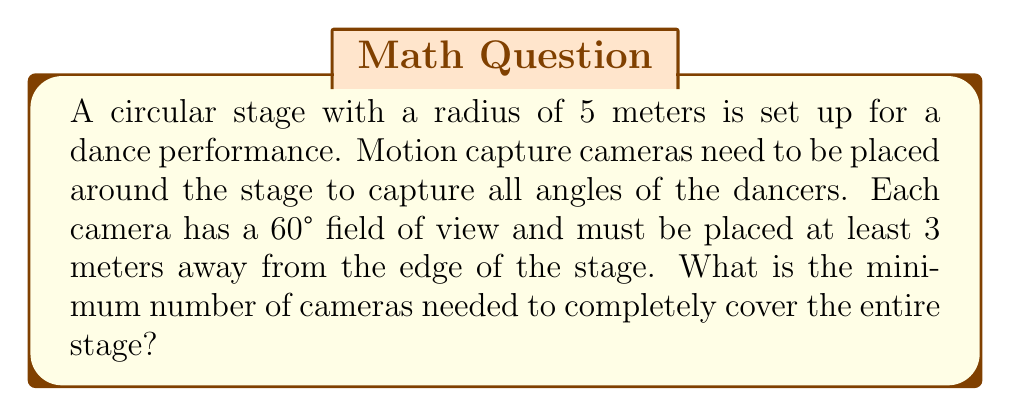Provide a solution to this math problem. Let's approach this step-by-step:

1) First, we need to calculate the circumference of the circle that the cameras will form around the stage. The radius of this circle is the stage radius plus the minimum distance of the cameras from the stage edge:

   $R = 5 + 3 = 8$ meters

   The circumference is then:
   $C = 2\pi R = 2\pi(8) = 16\pi$ meters

2) Each camera covers a 60° angle, which is $\frac{1}{6}$ of a full circle (360°).

3) The arc length covered by each camera at a distance of 8 meters from the center is:

   $L = \frac{60}{360} \cdot 2\pi R = \frac{1}{6} \cdot 2\pi(8) = \frac{8\pi}{3}$ meters

4) To find the number of cameras needed, we divide the total circumference by the arc length covered by each camera:

   $N = \frac{C}{L} = \frac{16\pi}{\frac{8\pi}{3}} = \frac{16\pi \cdot 3}{8\pi} = 6$

5) Since we can't use a fractional number of cameras, we need to round up to the nearest whole number.

Therefore, the minimum number of cameras needed is 6.

[asy]
unitsize(20);
draw(circle((0,0),5), blue);
draw(circle((0,0),8), red);
for(int i=0; i<6; ++i) {
  dot(8*dir(i*60), red);
}
label("Stage", (0,0));
label("Cameras", (8,0), E);
[/asy]
Answer: 6 cameras 